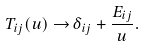<formula> <loc_0><loc_0><loc_500><loc_500>T _ { i j } ( u ) \rightarrow & \, \delta _ { i j } + \frac { E _ { i j } } { u } .</formula> 